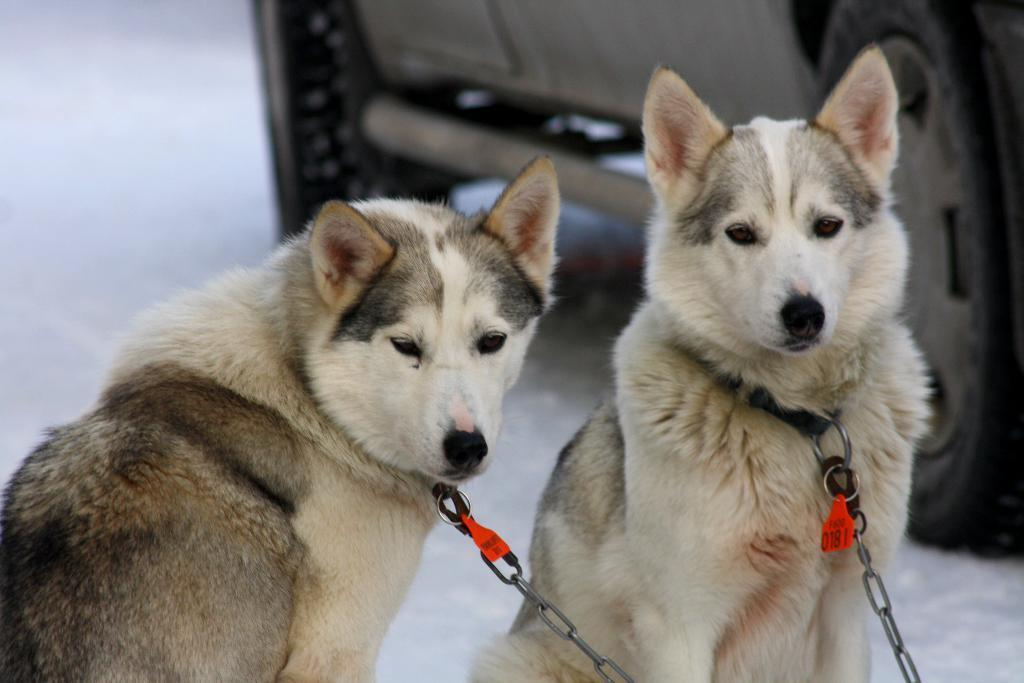How many dogs are present in the image? There are two dogs in the image. Where are the dogs located in the image? The dogs are in the middle of the image. What is visible behind the dogs in the image? There is a vehicle visible behind the dogs in the image. Can you see any ducks swimming in the water near the dogs in the image? There is no water or ducks present in the image. What type of pen is the dog holding in its mouth in the image? The dogs are not holding any pens in their mouths in the image. 